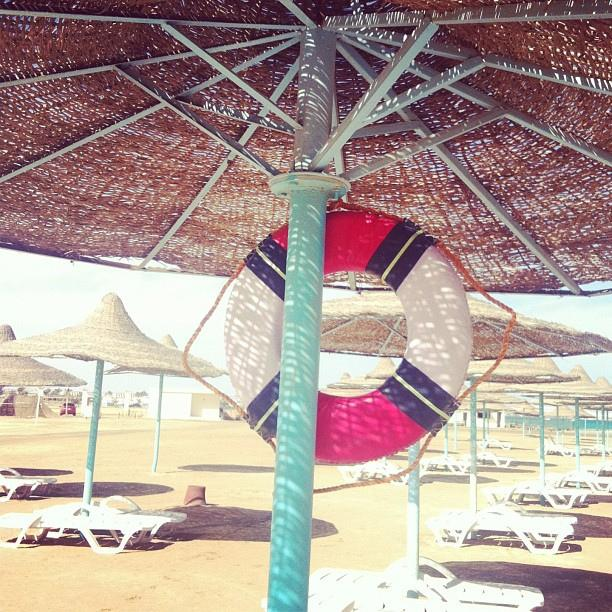The shade held by the teal umbrella pole was crafted in which manner? weaving 